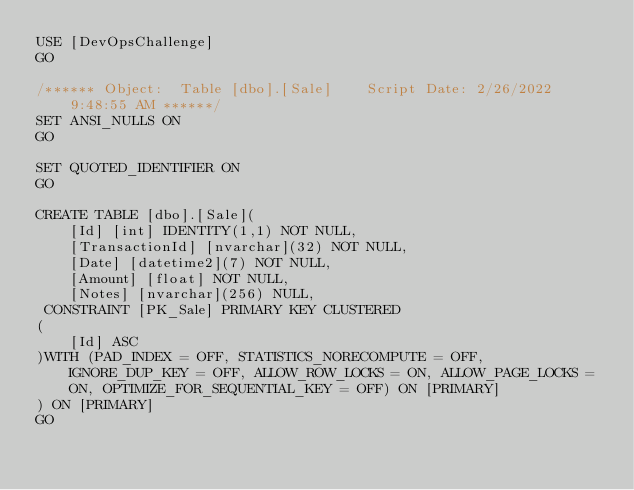<code> <loc_0><loc_0><loc_500><loc_500><_SQL_>USE [DevOpsChallenge]
GO

/****** Object:  Table [dbo].[Sale]    Script Date: 2/26/2022 9:48:55 AM ******/
SET ANSI_NULLS ON
GO

SET QUOTED_IDENTIFIER ON
GO

CREATE TABLE [dbo].[Sale](
	[Id] [int] IDENTITY(1,1) NOT NULL,
	[TransactionId] [nvarchar](32) NOT NULL,
	[Date] [datetime2](7) NOT NULL,
	[Amount] [float] NOT NULL,
	[Notes] [nvarchar](256) NULL,
 CONSTRAINT [PK_Sale] PRIMARY KEY CLUSTERED 
(
	[Id] ASC
)WITH (PAD_INDEX = OFF, STATISTICS_NORECOMPUTE = OFF, IGNORE_DUP_KEY = OFF, ALLOW_ROW_LOCKS = ON, ALLOW_PAGE_LOCKS = ON, OPTIMIZE_FOR_SEQUENTIAL_KEY = OFF) ON [PRIMARY]
) ON [PRIMARY]
GO


</code> 